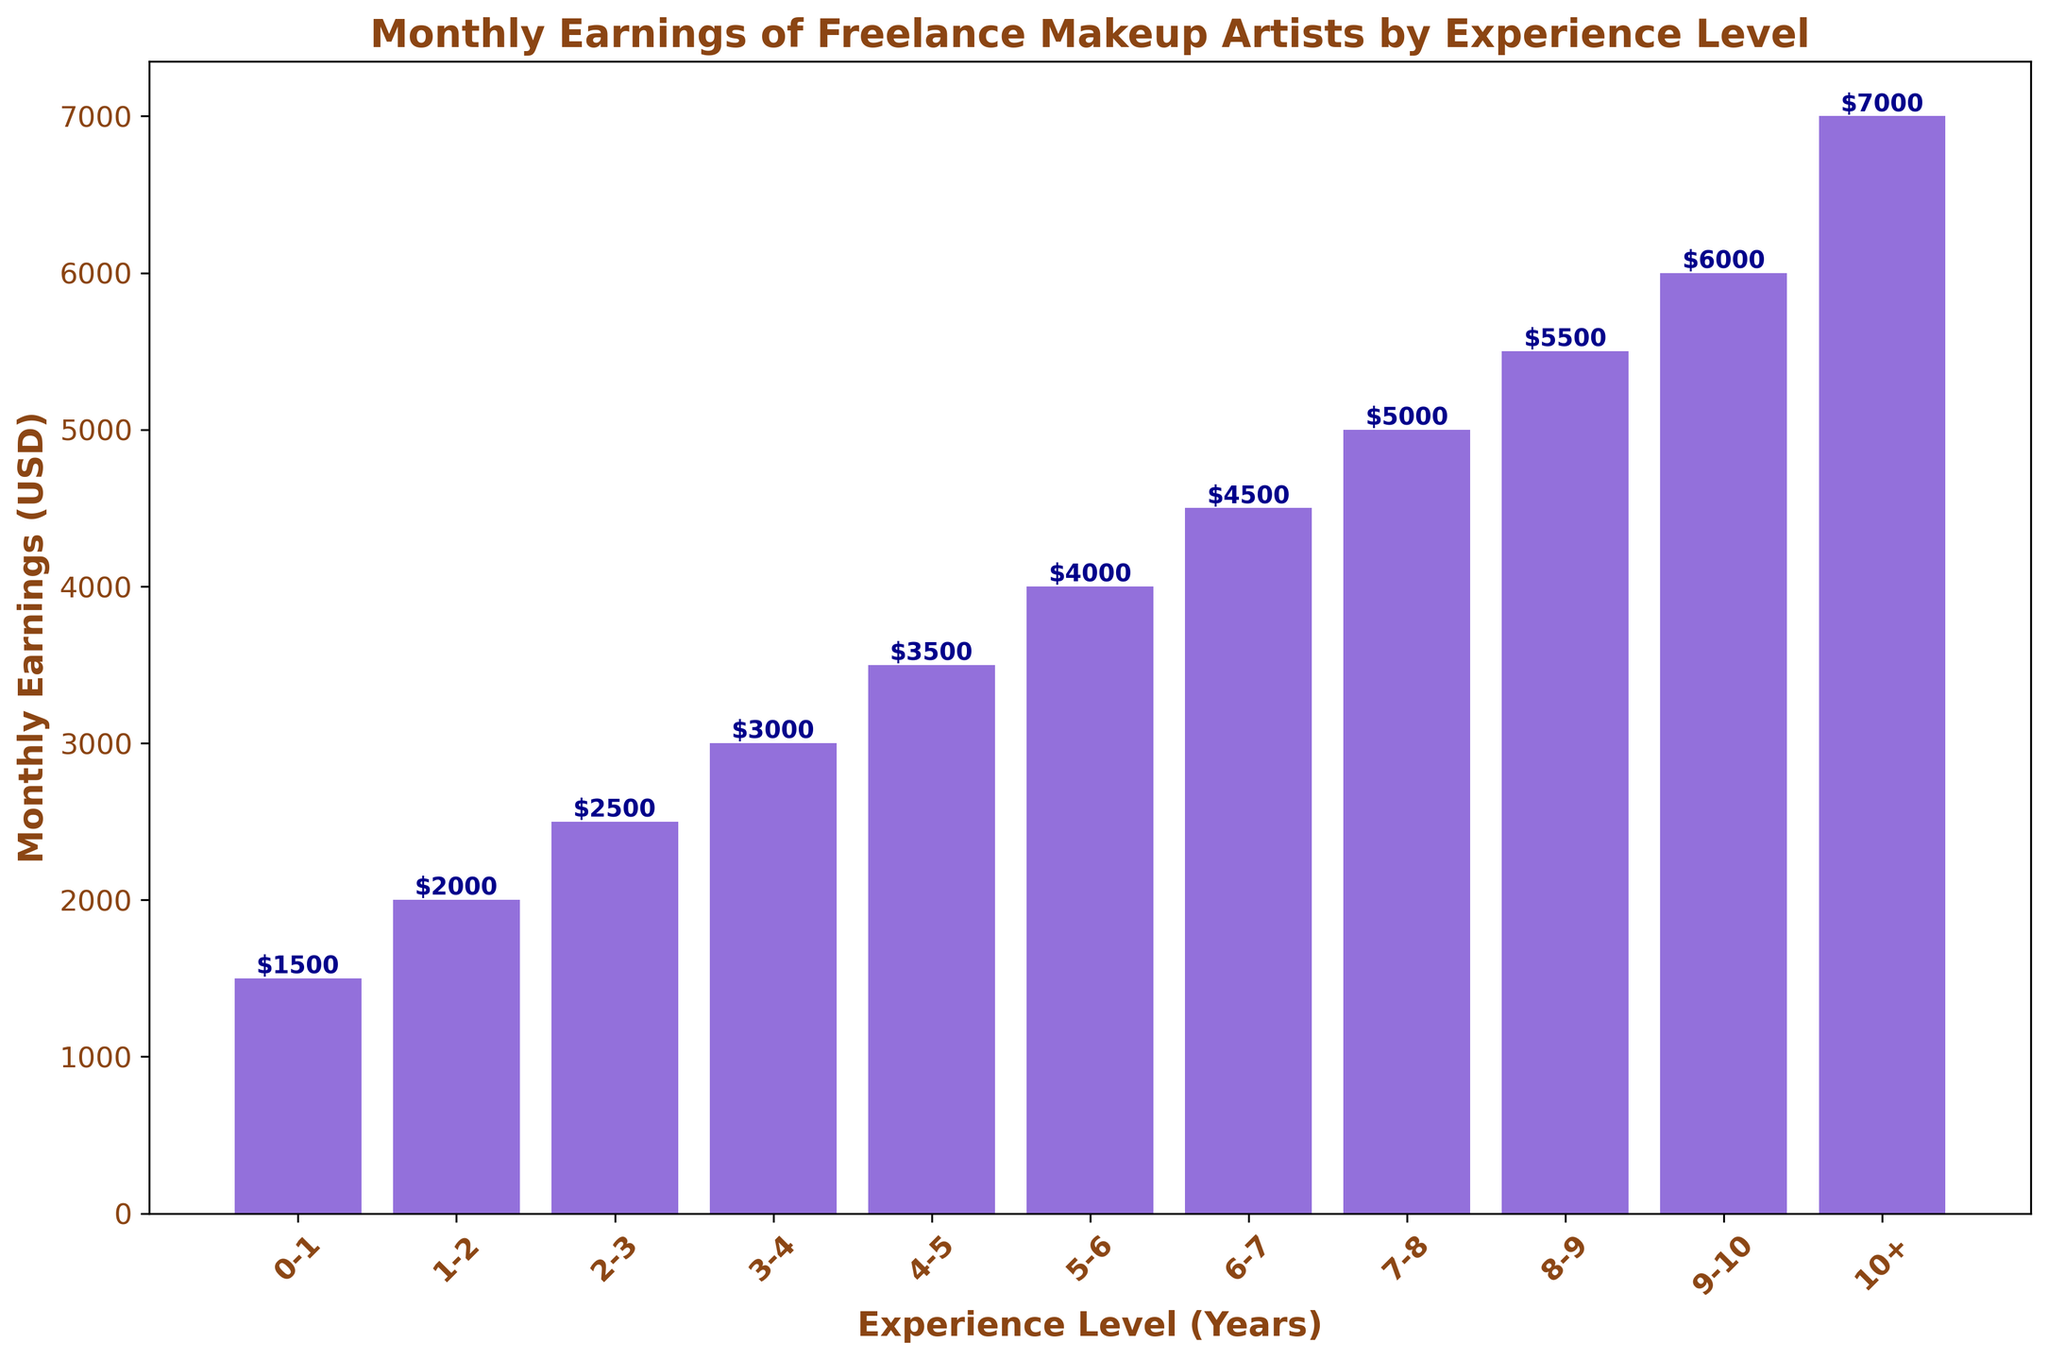What's the monthly earning difference between makeup artists with 4-5 years of experience and those with 7-8 years? The monthly earnings of makeup artists with 4-5 years of experience is $3500, and for those with 7-8 years of experience, it is $5000. To find the difference, subtract $3500 from $5000.
Answer: $1500 What is the average monthly earning of makeup artists with 0-3 years of experience? The monthly earnings for 0-1 year, 1-2 years, and 2-3 years of experience are $1500, $2000, and $2500 respectively. Sum these values and divide by 3: (1500 + 2000 + 2500) / 3.
Answer: $2000 Which experience level has the highest monthly earnings? From the chart, the bar representing 10+ years of experience has the highest height, indicating the highest earnings of $7000.
Answer: 10+ years How much more do makeup artists with 8-9 years of experience earn compared to those with 5-6 years? The monthly earnings for 8-9 years of experience is $5500, and for 5-6 years of experience, it is $4000. Subtract $4000 from $5500 to get the difference.
Answer: $1500 What is the total monthly earning of makeup artists with 6-8 years of experience combined? The monthly earnings for 6-7 years is $4500 and for 7-8 years is $5000. Add these two values together: $4500 + $5000.
Answer: $9500 Which experience levels have monthly earnings less than $3000? By examining the heights of the bars, experience levels with monthly earnings less than $3000 are 0-1 years, 1-2 years, 2-3 years, and 3-4 years.
Answer: 0-1, 1-2, 2-3, 3-4 years What is the median monthly earning of makeup artists from the given data? Arrange the earnings in ascending order: $1500, $2000, $2500, $3000, $3500, $4000, $4500, $5000, $5500, $6000, $7000. The middle value is the 6th entry, which is $4000.
Answer: $4000 How does the monthly earnings trend change as the years of experience increase? Observing the chart, the monthly earnings consistently increase as the years of experience increase, indicating a positive trend.
Answer: Increase What is the percentage increase in monthly earnings from makeup artists with 0-1 years to those with 10+ years of experience? The earnings for 0-1 years is $1500 and for 10+ years is $7000. Calculate the difference ($7000 - $1500 = $5500), then divide by the initial value ($5500 / $1500) and multiply by 100 to get the percentage.
Answer: 366.67% Which color is used to represent the bars in the chart? The color of the bars is mentioned as "mediumpurple."
Answer: Mediumpurple 